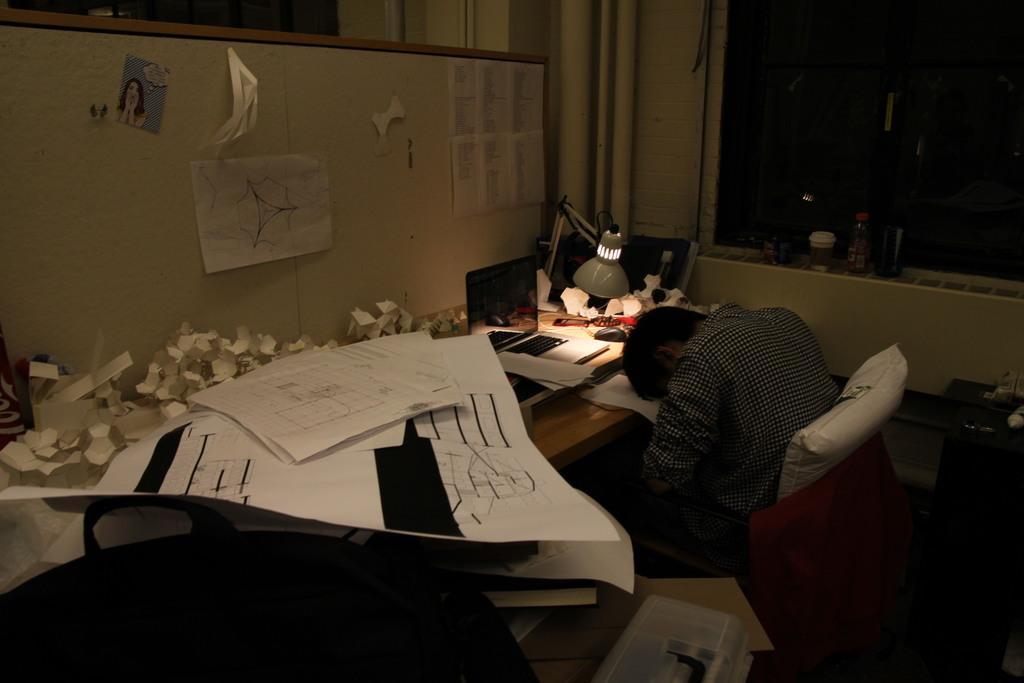Can you describe this image briefly? In this image, we can see a person sitting. We can see a table with some objects like a device, charts, a light and some posters. We can also see the wall with some posters. We can see a shelf with some objects like bottles. We can see the ground with a box. We can see some glass and a black colored object. 